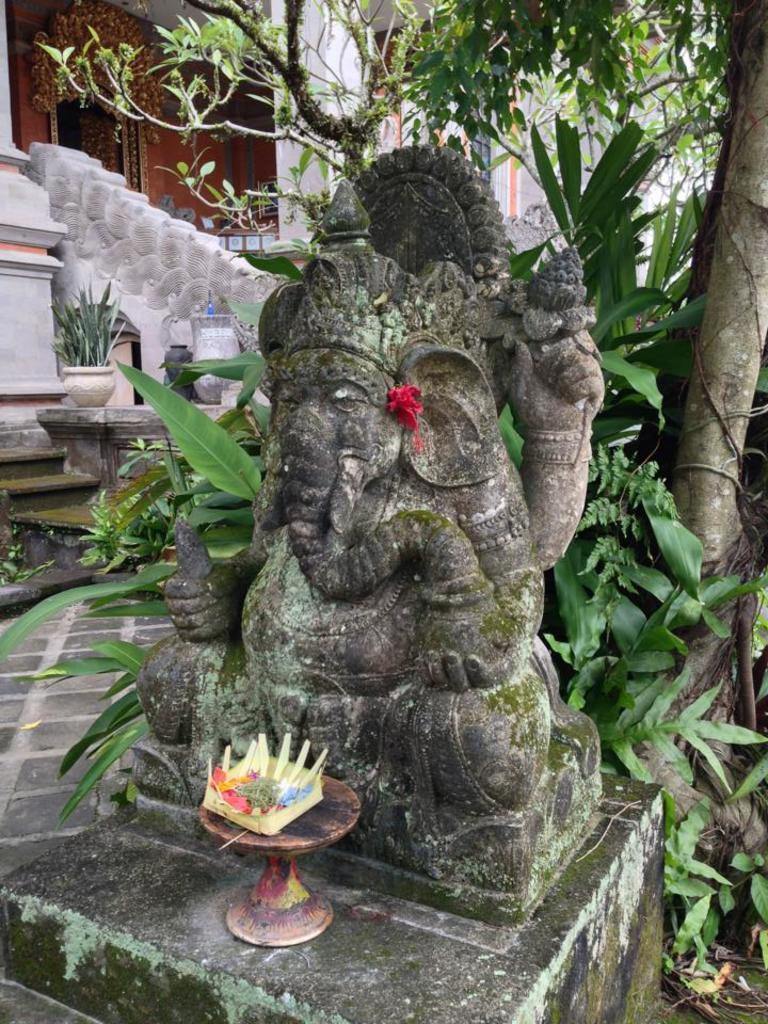In one or two sentences, can you explain what this image depicts? In this image I can see the statue of the god. In-front of the statue I can see an object on the stand. In the background I can see the trees, flower pot and the building. 